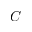Convert formula to latex. <formula><loc_0><loc_0><loc_500><loc_500>C</formula> 